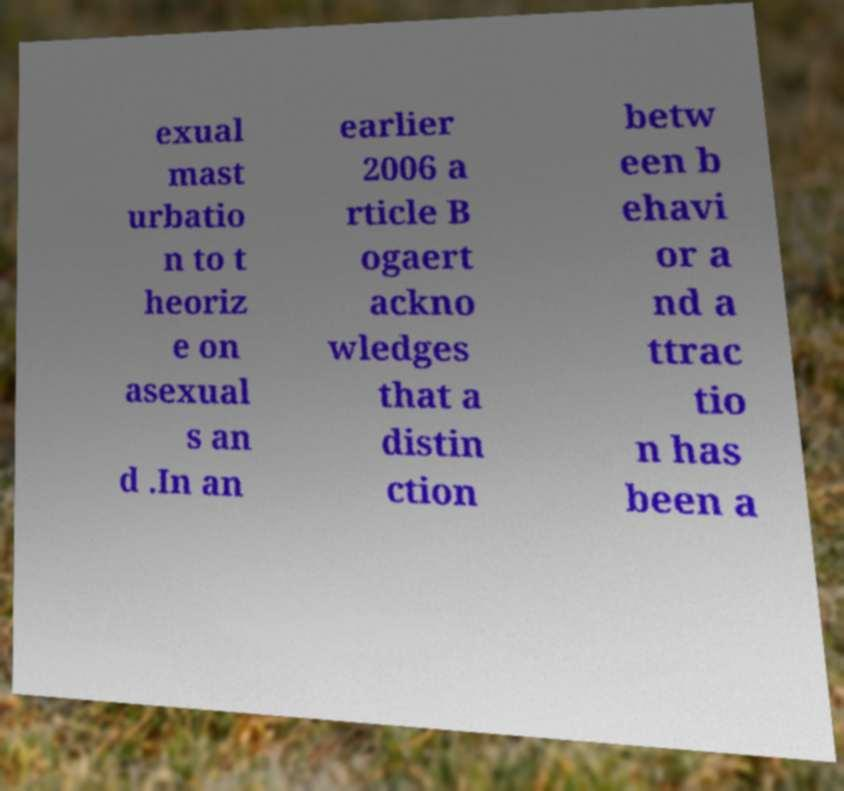Please identify and transcribe the text found in this image. exual mast urbatio n to t heoriz e on asexual s an d .In an earlier 2006 a rticle B ogaert ackno wledges that a distin ction betw een b ehavi or a nd a ttrac tio n has been a 